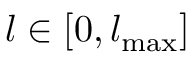Convert formula to latex. <formula><loc_0><loc_0><loc_500><loc_500>l \in [ 0 , { l _ { \max } } ]</formula> 